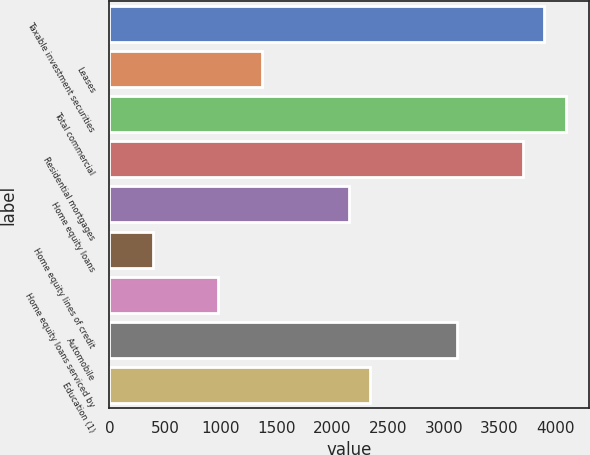<chart> <loc_0><loc_0><loc_500><loc_500><bar_chart><fcel>Taxable investment securities<fcel>Leases<fcel>Total commercial<fcel>Residential mortgages<fcel>Home equity loans<fcel>Home equity lines of credit<fcel>Home equity loans serviced by<fcel>Automobile<fcel>Education (1)<nl><fcel>3902<fcel>1367<fcel>4097<fcel>3707<fcel>2147<fcel>392<fcel>977<fcel>3122<fcel>2342<nl></chart> 